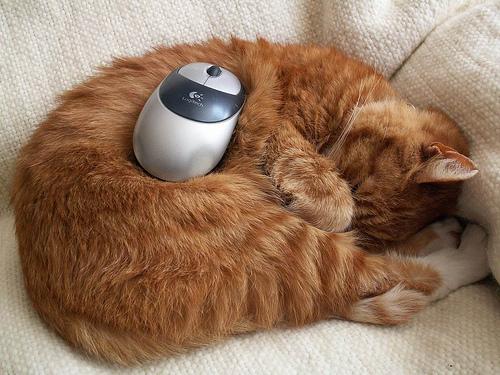Why is there a computer mouse on top of the cat?
Quick response, please. To be funny. Is the cat eating?
Quick response, please. No. What is laying on the cat?
Concise answer only. Mouse. 